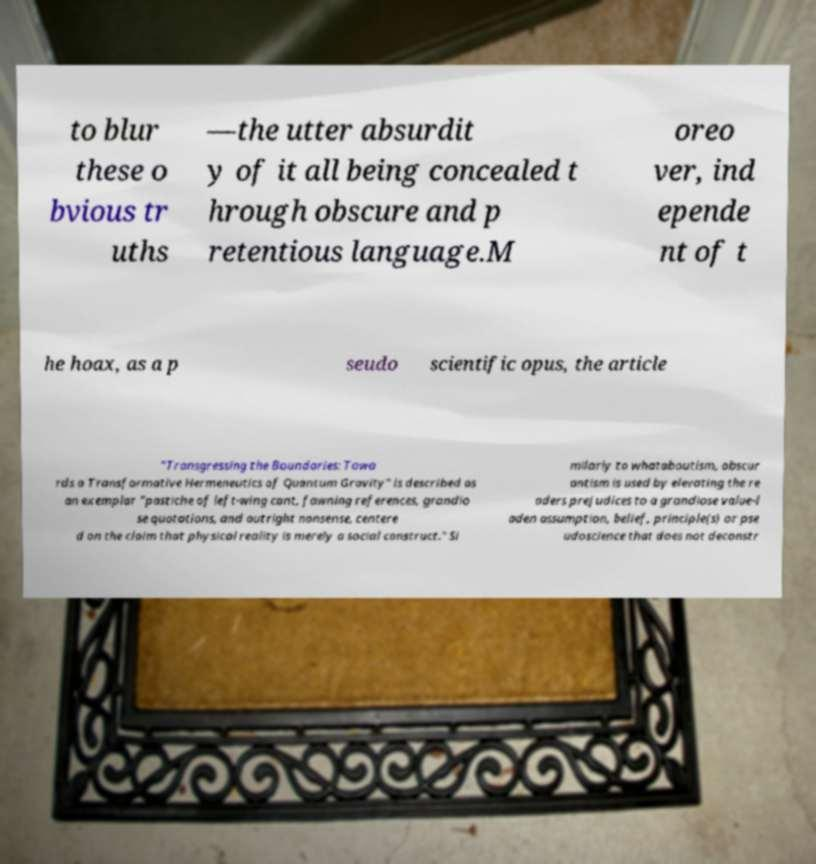There's text embedded in this image that I need extracted. Can you transcribe it verbatim? to blur these o bvious tr uths —the utter absurdit y of it all being concealed t hrough obscure and p retentious language.M oreo ver, ind epende nt of t he hoax, as a p seudo scientific opus, the article "Transgressing the Boundaries: Towa rds a Transformative Hermeneutics of Quantum Gravity" is described as an exemplar "pastiche of left-wing cant, fawning references, grandio se quotations, and outright nonsense, centere d on the claim that physical reality is merely a social construct." Si milarly to whataboutism, obscur antism is used by elevating the re aders prejudices to a grandiose value-l aden assumption, belief, principle(s) or pse udoscience that does not deconstr 